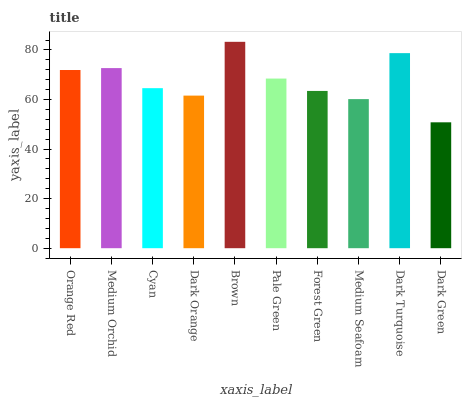Is Dark Green the minimum?
Answer yes or no. Yes. Is Brown the maximum?
Answer yes or no. Yes. Is Medium Orchid the minimum?
Answer yes or no. No. Is Medium Orchid the maximum?
Answer yes or no. No. Is Medium Orchid greater than Orange Red?
Answer yes or no. Yes. Is Orange Red less than Medium Orchid?
Answer yes or no. Yes. Is Orange Red greater than Medium Orchid?
Answer yes or no. No. Is Medium Orchid less than Orange Red?
Answer yes or no. No. Is Pale Green the high median?
Answer yes or no. Yes. Is Cyan the low median?
Answer yes or no. Yes. Is Dark Green the high median?
Answer yes or no. No. Is Medium Orchid the low median?
Answer yes or no. No. 